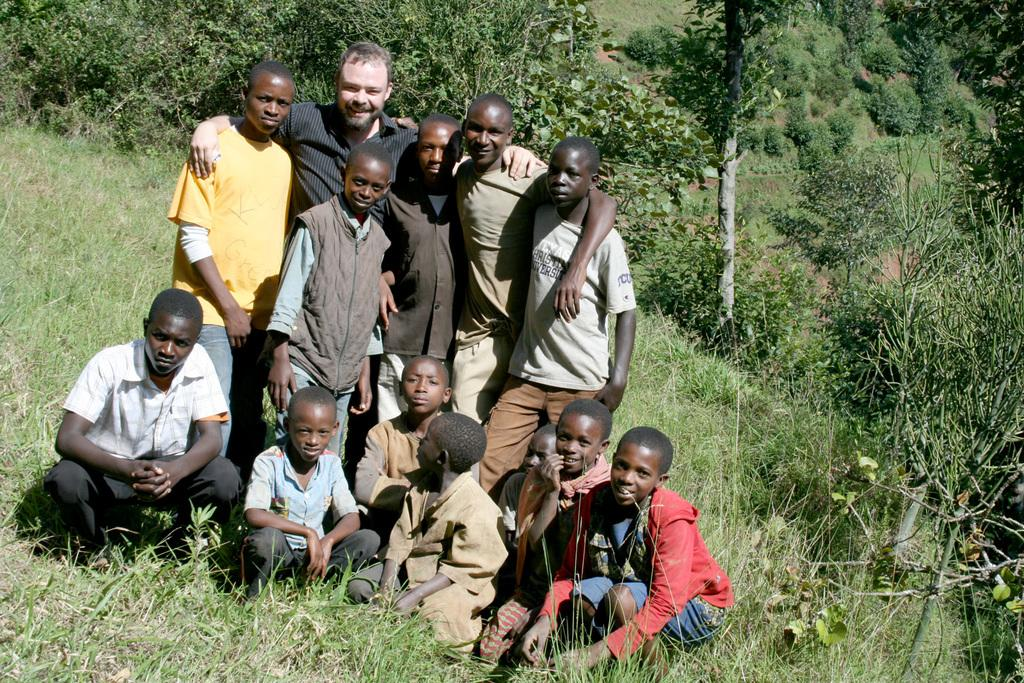What are the people in the image doing? There are people standing and sitting in the image. Where are the people located in the image? The people are on the grass. What can be seen in the background of the image? There are trees in the background of the image. How many ants can be seen crawling on the people in the image? There are no ants visible in the image; it only shows people standing and sitting on the grass. What type of star can be heard singing in the background of the image? There is no star present in the image, nor is there any sound or music mentioned. 